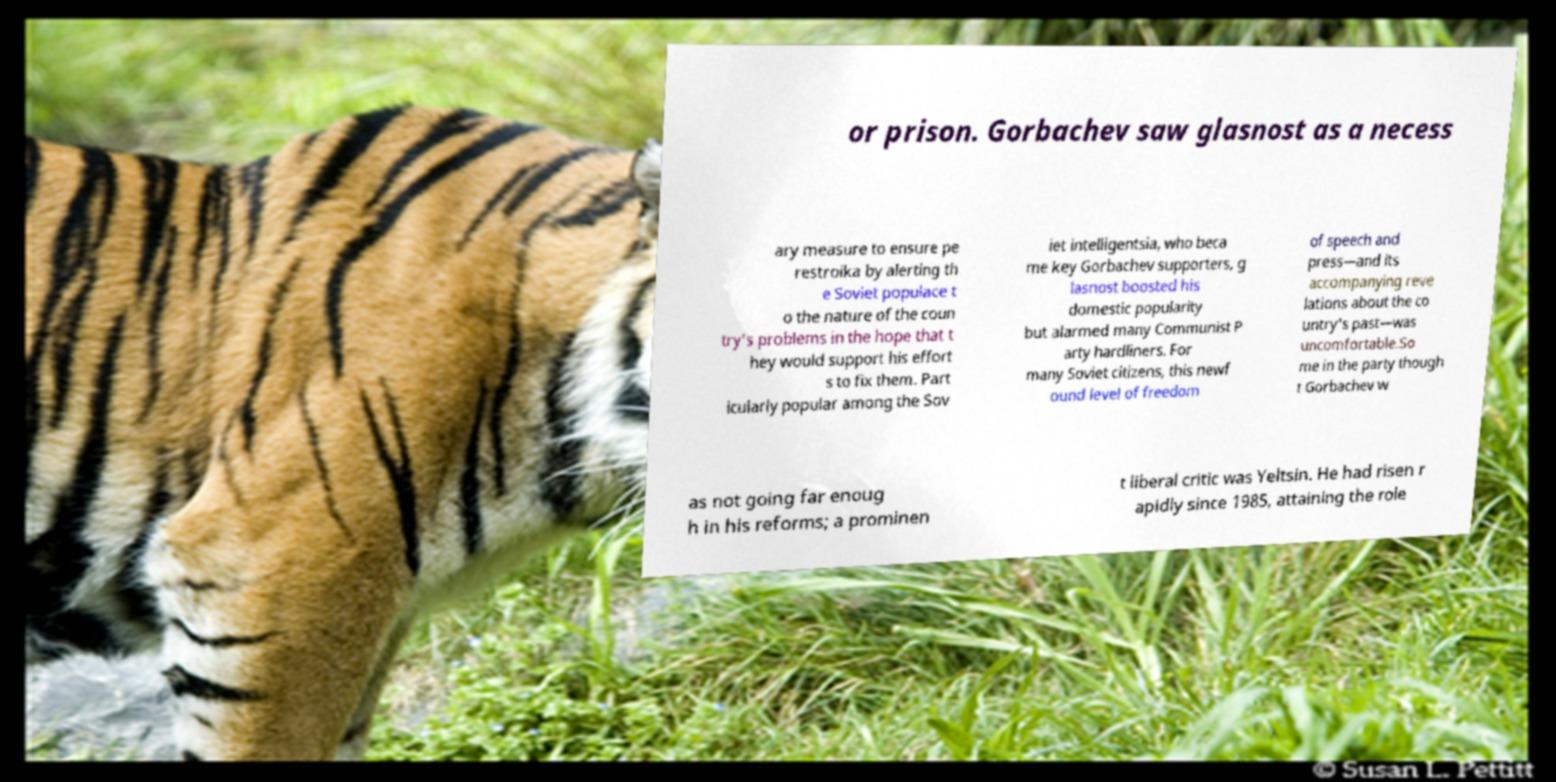Can you read and provide the text displayed in the image?This photo seems to have some interesting text. Can you extract and type it out for me? or prison. Gorbachev saw glasnost as a necess ary measure to ensure pe restroika by alerting th e Soviet populace t o the nature of the coun try's problems in the hope that t hey would support his effort s to fix them. Part icularly popular among the Sov iet intelligentsia, who beca me key Gorbachev supporters, g lasnost boosted his domestic popularity but alarmed many Communist P arty hardliners. For many Soviet citizens, this newf ound level of freedom of speech and press—and its accompanying reve lations about the co untry's past—was uncomfortable.So me in the party though t Gorbachev w as not going far enoug h in his reforms; a prominen t liberal critic was Yeltsin. He had risen r apidly since 1985, attaining the role 